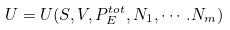<formula> <loc_0><loc_0><loc_500><loc_500>U = U ( S , V , P ^ { t o t } _ { E } , N _ { 1 } , \cdots . N _ { m } )</formula> 